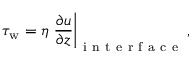<formula> <loc_0><loc_0><loc_500><loc_500>\tau _ { w } = \eta \frac { \partial u } { \partial z } \right | _ { i n t e r f a c e } ,</formula> 